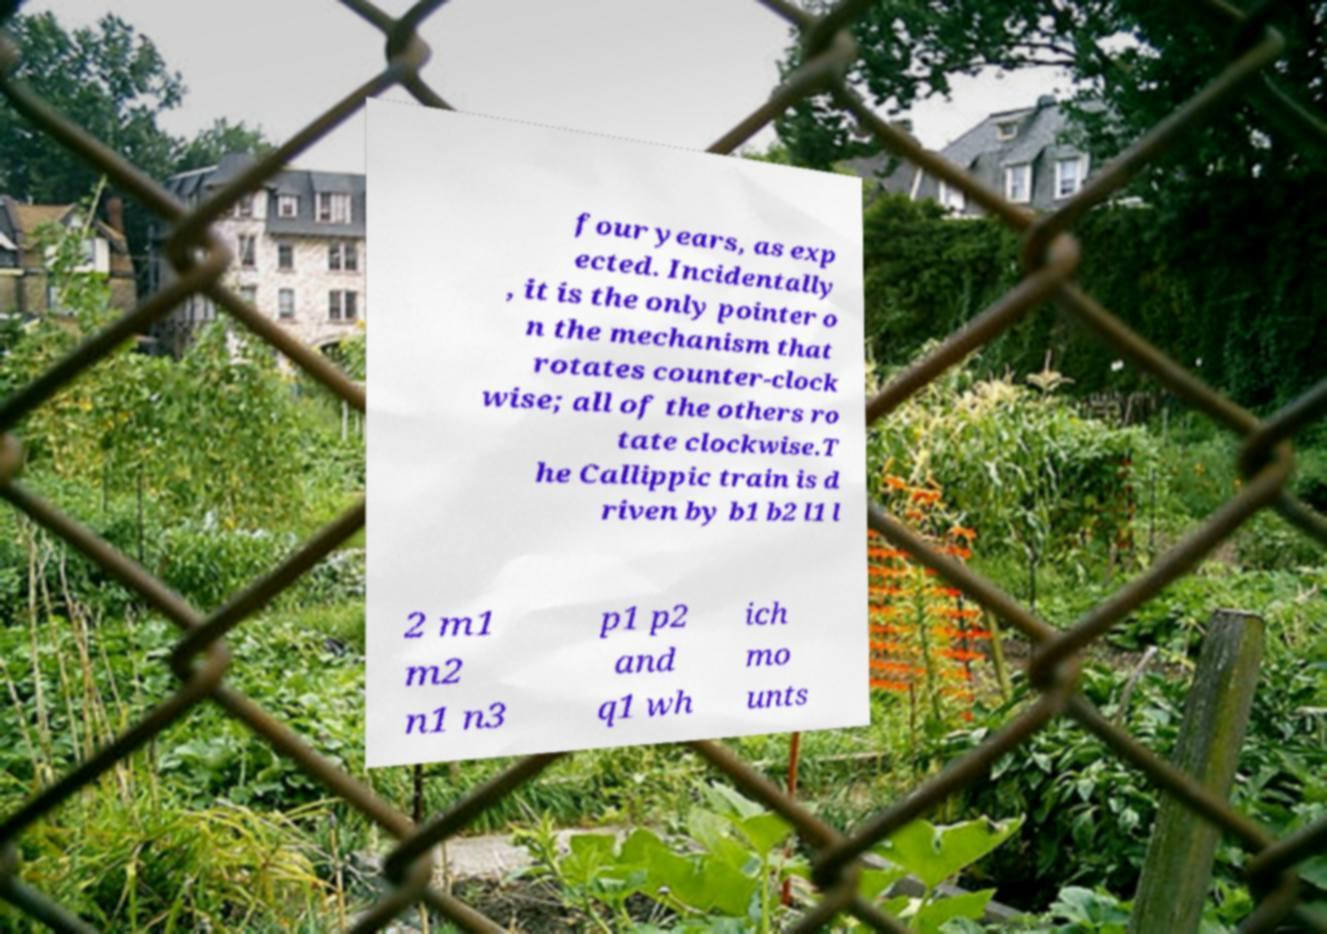What messages or text are displayed in this image? I need them in a readable, typed format. four years, as exp ected. Incidentally , it is the only pointer o n the mechanism that rotates counter-clock wise; all of the others ro tate clockwise.T he Callippic train is d riven by b1 b2 l1 l 2 m1 m2 n1 n3 p1 p2 and q1 wh ich mo unts 